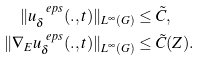<formula> <loc_0><loc_0><loc_500><loc_500>\| u ^ { \ e p s } _ { \delta } ( . , t ) \| _ { L ^ { \infty } ( G ) } & \leq \tilde { C } , \\ \| \nabla _ { E } u ^ { \ e p s } _ { \delta } ( . , t ) \| _ { L ^ { \infty } ( G ) } & \leq { \tilde { C } } ( Z ) .</formula> 